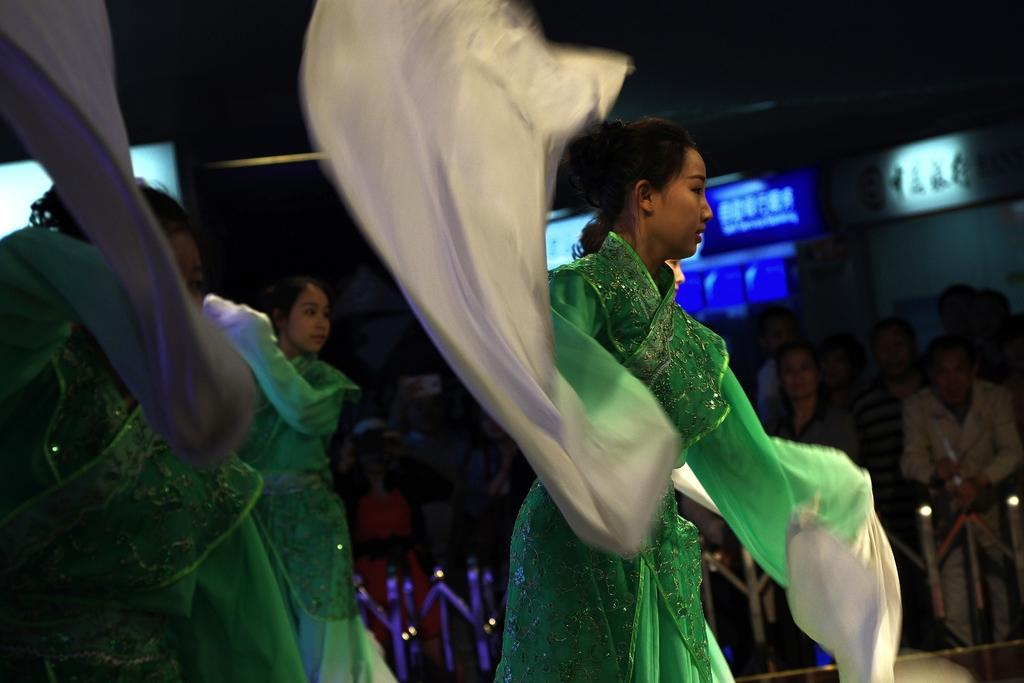What are the ladies in the image doing? The ladies in the image are dancing. Can you describe the people in the background? There are people standing in the background. What separates the people in the background from the dancing ladies? The people in the background are behind a railing. What objects can be seen in the image besides the people? There are boards visible in the image. Can you tell me how many oranges are on the hill in the image? There is no hill or oranges present in the image. What type of songs are the ladies singing while dancing in the image? The image does not provide any information about the songs being sung by the ladies while dancing. 